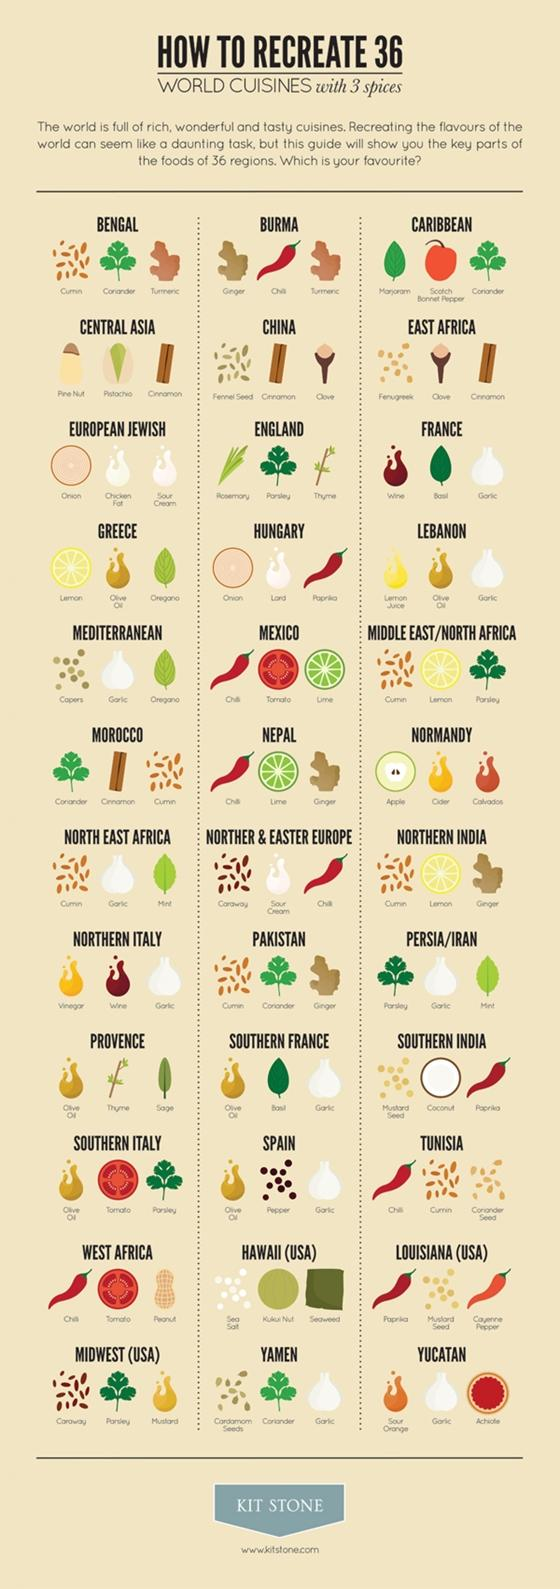Identify some key points in this picture. There are three regions in India that are recognized as having significant contributions to world cuisine. There are six regions that heavily incorporate olive oil into their cuisine. Four regions use mint for their cooking. Two countries or regions, Bengal and Burma, utilize Tamarind in their culinary practices. Nine countries use red paprika in their cuisine. 